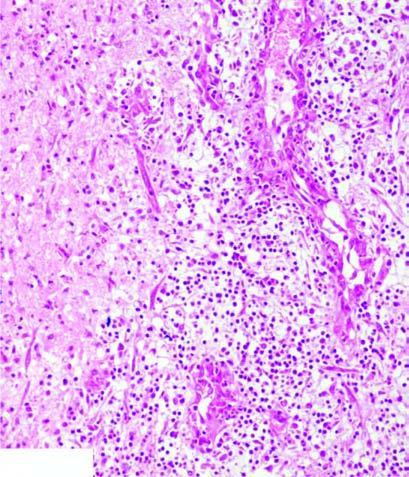what shows granulation tissue and gliosis?
Answer the question using a single word or phrase. The surrounding zone gliosis 